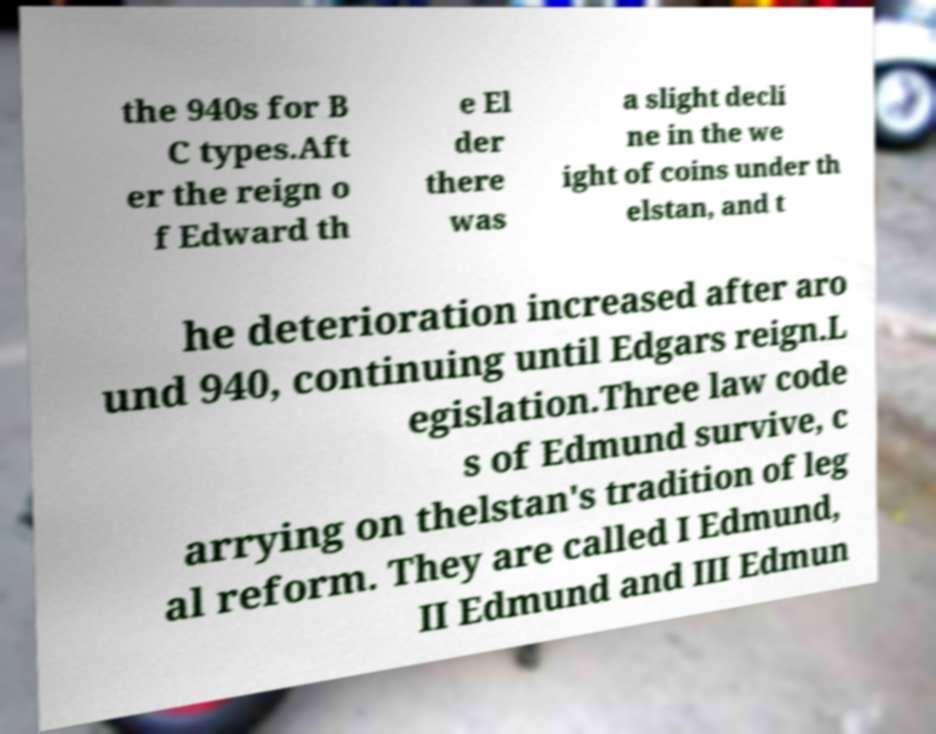Can you accurately transcribe the text from the provided image for me? the 940s for B C types.Aft er the reign o f Edward th e El der there was a slight decli ne in the we ight of coins under th elstan, and t he deterioration increased after aro und 940, continuing until Edgars reign.L egislation.Three law code s of Edmund survive, c arrying on thelstan's tradition of leg al reform. They are called I Edmund, II Edmund and III Edmun 